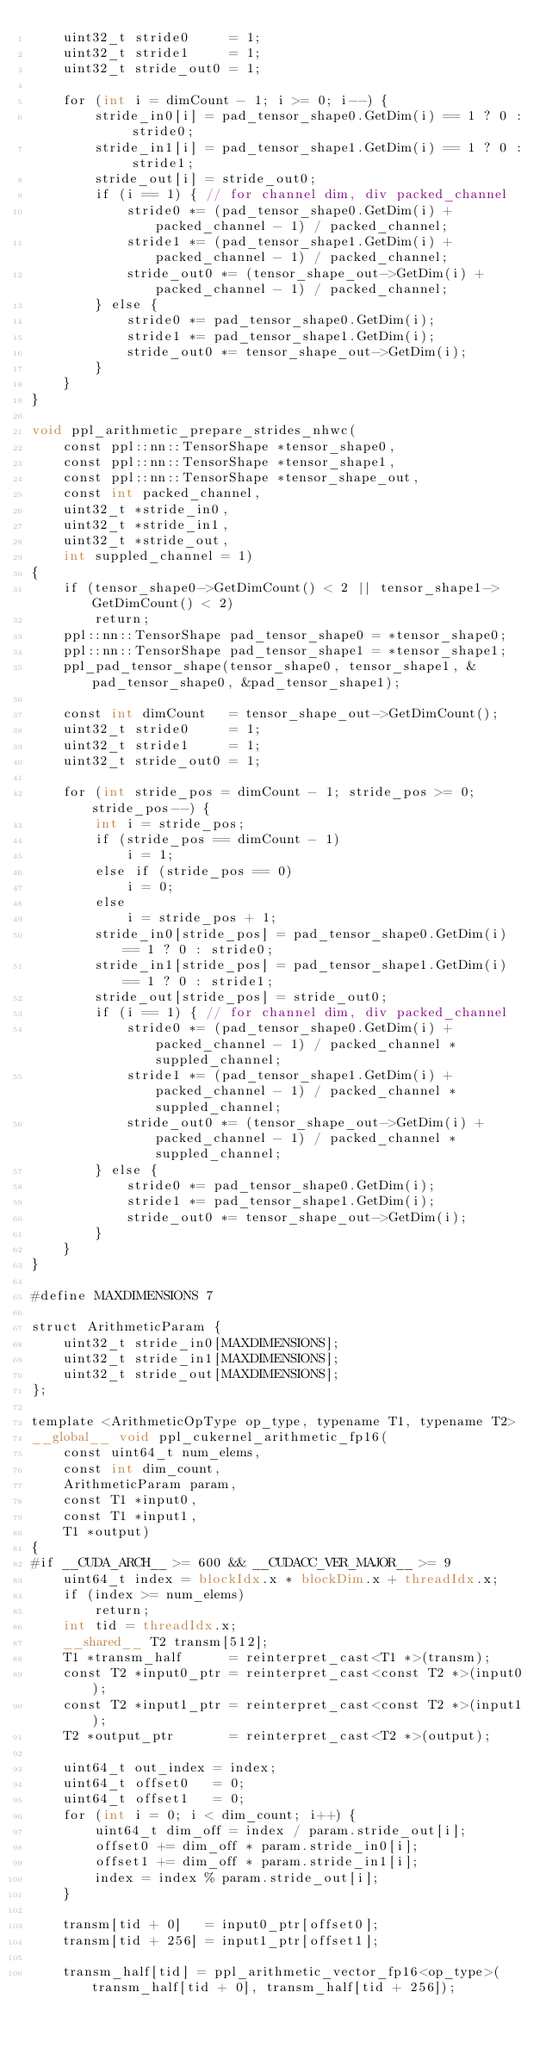<code> <loc_0><loc_0><loc_500><loc_500><_Cuda_>    uint32_t stride0     = 1;
    uint32_t stride1     = 1;
    uint32_t stride_out0 = 1;

    for (int i = dimCount - 1; i >= 0; i--) {
        stride_in0[i] = pad_tensor_shape0.GetDim(i) == 1 ? 0 : stride0;
        stride_in1[i] = pad_tensor_shape1.GetDim(i) == 1 ? 0 : stride1;
        stride_out[i] = stride_out0;
        if (i == 1) { // for channel dim, div packed_channel
            stride0 *= (pad_tensor_shape0.GetDim(i) + packed_channel - 1) / packed_channel;
            stride1 *= (pad_tensor_shape1.GetDim(i) + packed_channel - 1) / packed_channel;
            stride_out0 *= (tensor_shape_out->GetDim(i) + packed_channel - 1) / packed_channel;
        } else {
            stride0 *= pad_tensor_shape0.GetDim(i);
            stride1 *= pad_tensor_shape1.GetDim(i);
            stride_out0 *= tensor_shape_out->GetDim(i);
        }
    }
}

void ppl_arithmetic_prepare_strides_nhwc(
    const ppl::nn::TensorShape *tensor_shape0,
    const ppl::nn::TensorShape *tensor_shape1,
    const ppl::nn::TensorShape *tensor_shape_out,
    const int packed_channel,
    uint32_t *stride_in0,
    uint32_t *stride_in1,
    uint32_t *stride_out,
    int suppled_channel = 1)
{
    if (tensor_shape0->GetDimCount() < 2 || tensor_shape1->GetDimCount() < 2)
        return;
    ppl::nn::TensorShape pad_tensor_shape0 = *tensor_shape0;
    ppl::nn::TensorShape pad_tensor_shape1 = *tensor_shape1;
    ppl_pad_tensor_shape(tensor_shape0, tensor_shape1, &pad_tensor_shape0, &pad_tensor_shape1);

    const int dimCount   = tensor_shape_out->GetDimCount();
    uint32_t stride0     = 1;
    uint32_t stride1     = 1;
    uint32_t stride_out0 = 1;

    for (int stride_pos = dimCount - 1; stride_pos >= 0; stride_pos--) {
        int i = stride_pos;
        if (stride_pos == dimCount - 1)
            i = 1;
        else if (stride_pos == 0)
            i = 0;
        else
            i = stride_pos + 1;
        stride_in0[stride_pos] = pad_tensor_shape0.GetDim(i) == 1 ? 0 : stride0;
        stride_in1[stride_pos] = pad_tensor_shape1.GetDim(i) == 1 ? 0 : stride1;
        stride_out[stride_pos] = stride_out0;
        if (i == 1) { // for channel dim, div packed_channel
            stride0 *= (pad_tensor_shape0.GetDim(i) + packed_channel - 1) / packed_channel * suppled_channel;
            stride1 *= (pad_tensor_shape1.GetDim(i) + packed_channel - 1) / packed_channel * suppled_channel;
            stride_out0 *= (tensor_shape_out->GetDim(i) + packed_channel - 1) / packed_channel * suppled_channel;
        } else {
            stride0 *= pad_tensor_shape0.GetDim(i);
            stride1 *= pad_tensor_shape1.GetDim(i);
            stride_out0 *= tensor_shape_out->GetDim(i);
        }
    }
}

#define MAXDIMENSIONS 7

struct ArithmeticParam {
    uint32_t stride_in0[MAXDIMENSIONS];
    uint32_t stride_in1[MAXDIMENSIONS];
    uint32_t stride_out[MAXDIMENSIONS];
};

template <ArithmeticOpType op_type, typename T1, typename T2>
__global__ void ppl_cukernel_arithmetic_fp16(
    const uint64_t num_elems,
    const int dim_count,
    ArithmeticParam param,
    const T1 *input0,
    const T1 *input1,
    T1 *output)
{
#if __CUDA_ARCH__ >= 600 && __CUDACC_VER_MAJOR__ >= 9
    uint64_t index = blockIdx.x * blockDim.x + threadIdx.x;
    if (index >= num_elems)
        return;
    int tid = threadIdx.x;
    __shared__ T2 transm[512];
    T1 *transm_half      = reinterpret_cast<T1 *>(transm);
    const T2 *input0_ptr = reinterpret_cast<const T2 *>(input0);
    const T2 *input1_ptr = reinterpret_cast<const T2 *>(input1);
    T2 *output_ptr       = reinterpret_cast<T2 *>(output);

    uint64_t out_index = index;
    uint64_t offset0   = 0;
    uint64_t offset1   = 0;
    for (int i = 0; i < dim_count; i++) {
        uint64_t dim_off = index / param.stride_out[i];
        offset0 += dim_off * param.stride_in0[i];
        offset1 += dim_off * param.stride_in1[i];
        index = index % param.stride_out[i];
    }

    transm[tid + 0]   = input0_ptr[offset0];
    transm[tid + 256] = input1_ptr[offset1];

    transm_half[tid] = ppl_arithmetic_vector_fp16<op_type>(transm_half[tid + 0], transm_half[tid + 256]);
</code> 